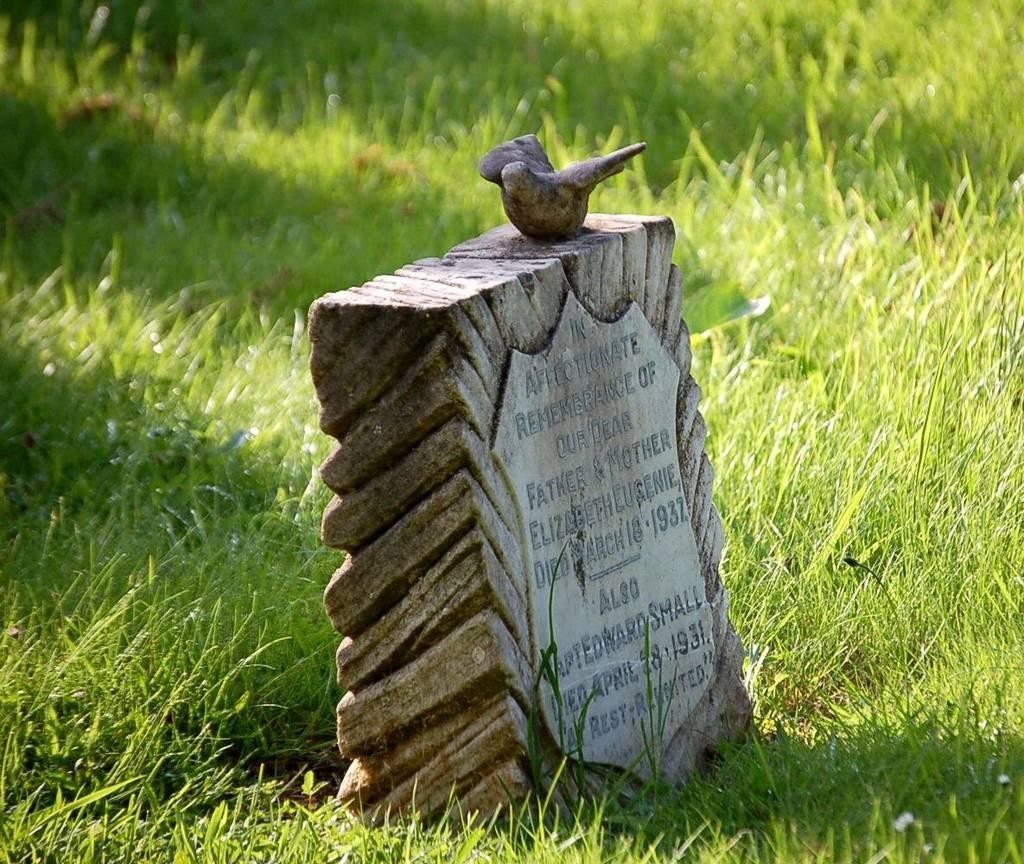What type of surface can be seen in the image? There is a path in the grass in the image. Can you describe the path in the image? The path is made of grass and can be seen winding through the grassy area. How does the rice affect the path in the image? There is no rice present in the image, so it cannot affect the path. 